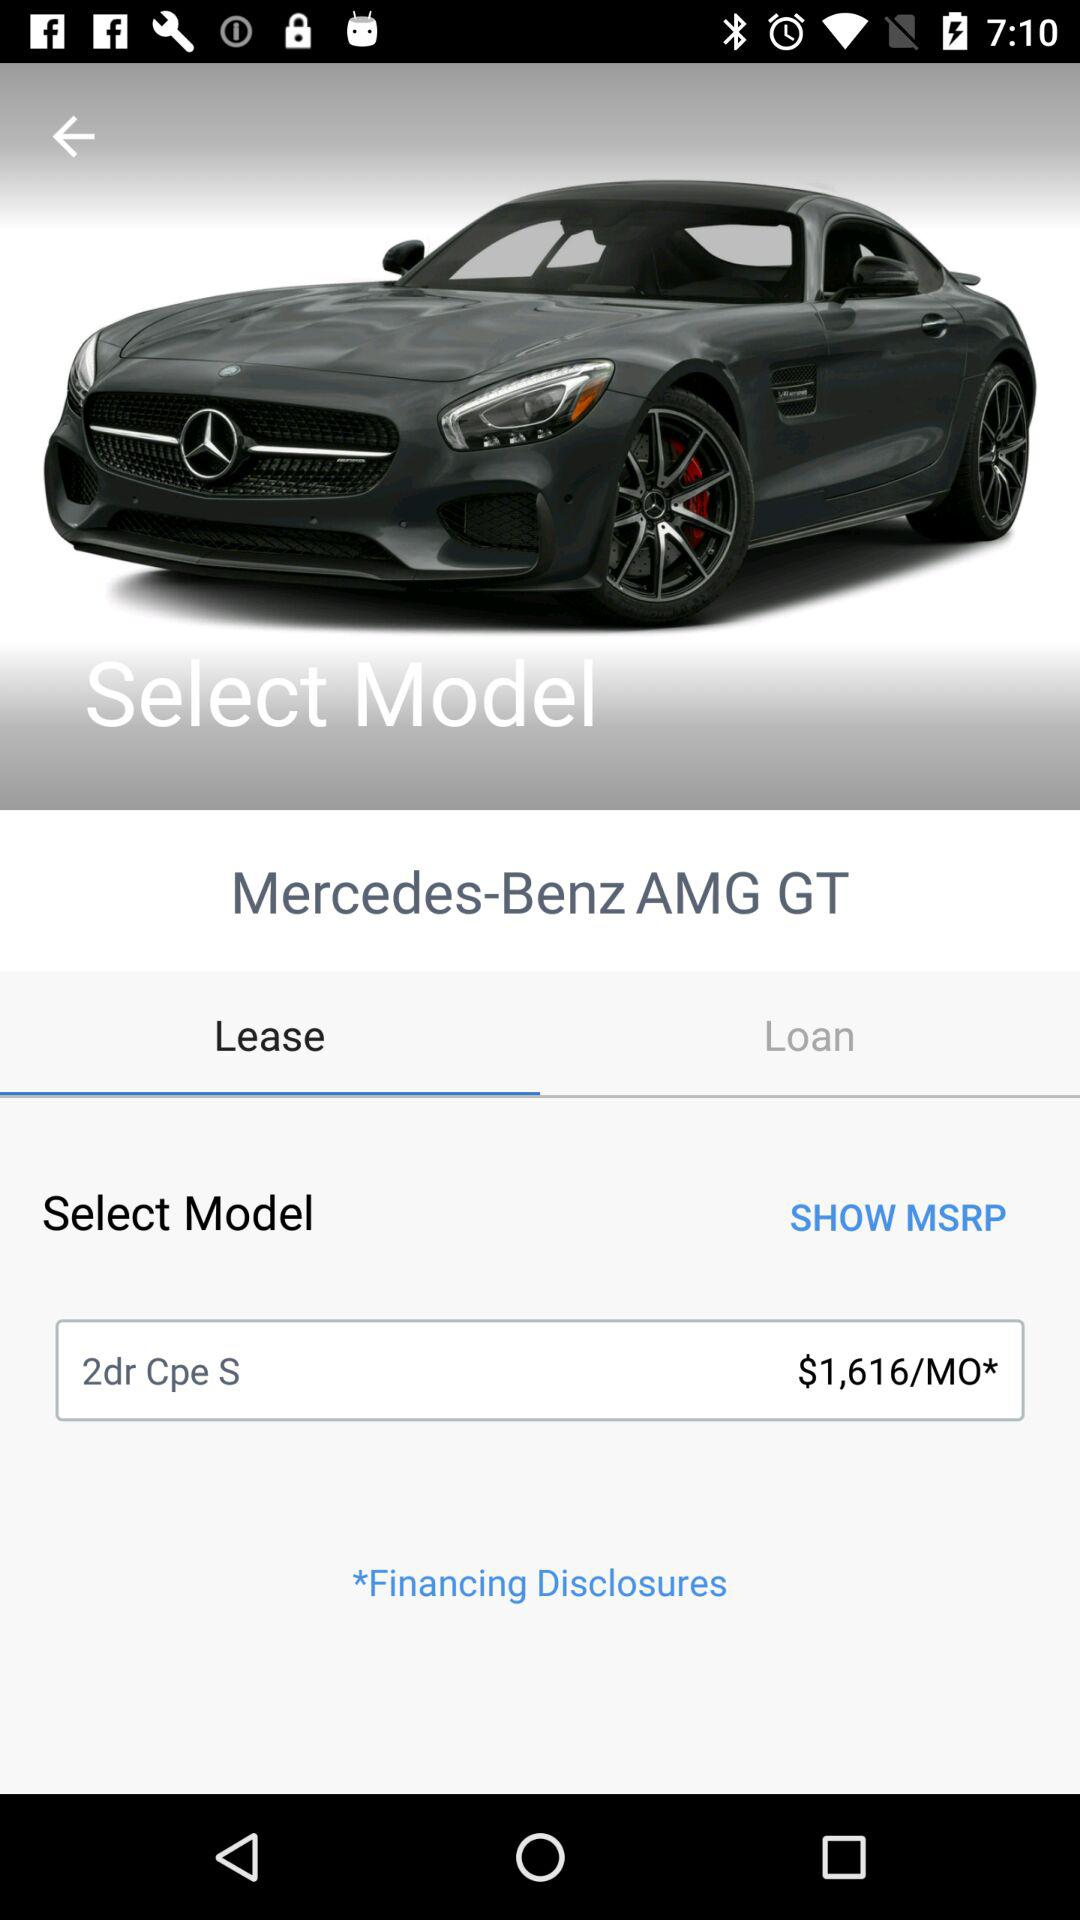What's the selected model? The selected model is "2dr Cpe S". 